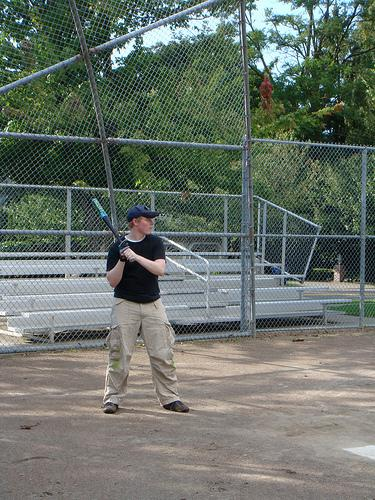Question: who is wearing beige pants and a black shirt?
Choices:
A. A coach.
B. A pitcher.
C. A batter.
D. A referee.
Answer with the letter. Answer: C Question: what is the guy in the black shirt waiting for?
Choices:
A. The referee.
B. The ball.
C. The batter.
D. The pitcher.
Answer with the letter. Answer: B Question: how many players are visible?
Choices:
A. Just one.
B. One.
C. Only one.
D. A single player.
Answer with the letter. Answer: A Question: what is the batter wearing on his head?
Choices:
A. A catcher's guard.
B. A protective helmet.
C. A messy mass of unkempt hair.
D. A baseball cap.
Answer with the letter. Answer: D Question: what material is the fence made of?
Choices:
A. Wood.
B. Metal.
C. Plastic.
D. Pvc.
Answer with the letter. Answer: B Question: where are the trees?
Choices:
A. Alongside the road.
B. Near the buildings.
C. Opposite the tracks.
D. Behind the stands.
Answer with the letter. Answer: D 